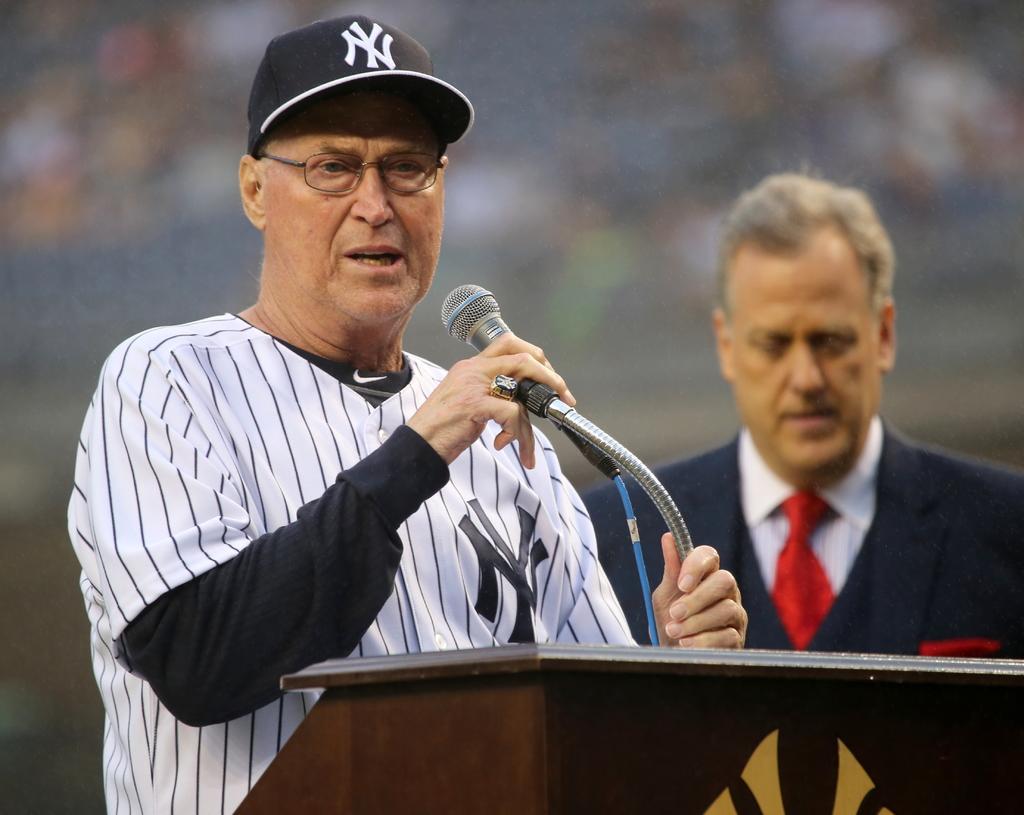Describe this image in one or two sentences. In this image I can see two people with different color dresses. I can see one person standing in-front of the podium. On the podium there is a mic. I can also see the person wearing the cap. And there is a blurred background. 